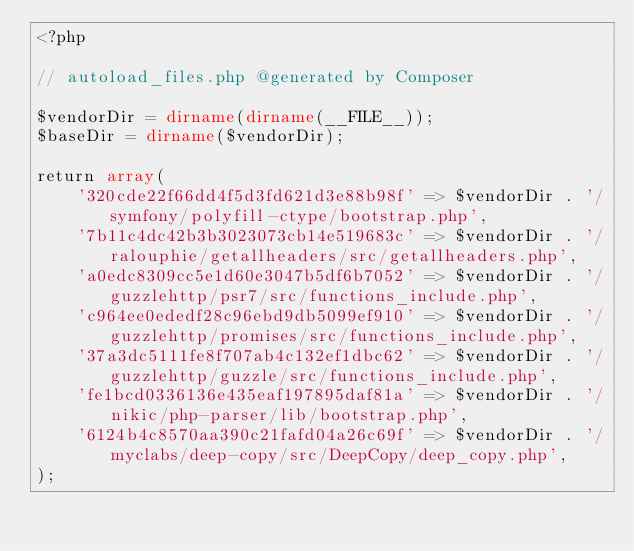<code> <loc_0><loc_0><loc_500><loc_500><_PHP_><?php

// autoload_files.php @generated by Composer

$vendorDir = dirname(dirname(__FILE__));
$baseDir = dirname($vendorDir);

return array(
    '320cde22f66dd4f5d3fd621d3e88b98f' => $vendorDir . '/symfony/polyfill-ctype/bootstrap.php',
    '7b11c4dc42b3b3023073cb14e519683c' => $vendorDir . '/ralouphie/getallheaders/src/getallheaders.php',
    'a0edc8309cc5e1d60e3047b5df6b7052' => $vendorDir . '/guzzlehttp/psr7/src/functions_include.php',
    'c964ee0ededf28c96ebd9db5099ef910' => $vendorDir . '/guzzlehttp/promises/src/functions_include.php',
    '37a3dc5111fe8f707ab4c132ef1dbc62' => $vendorDir . '/guzzlehttp/guzzle/src/functions_include.php',
    'fe1bcd0336136e435eaf197895daf81a' => $vendorDir . '/nikic/php-parser/lib/bootstrap.php',
    '6124b4c8570aa390c21fafd04a26c69f' => $vendorDir . '/myclabs/deep-copy/src/DeepCopy/deep_copy.php',
);
</code> 